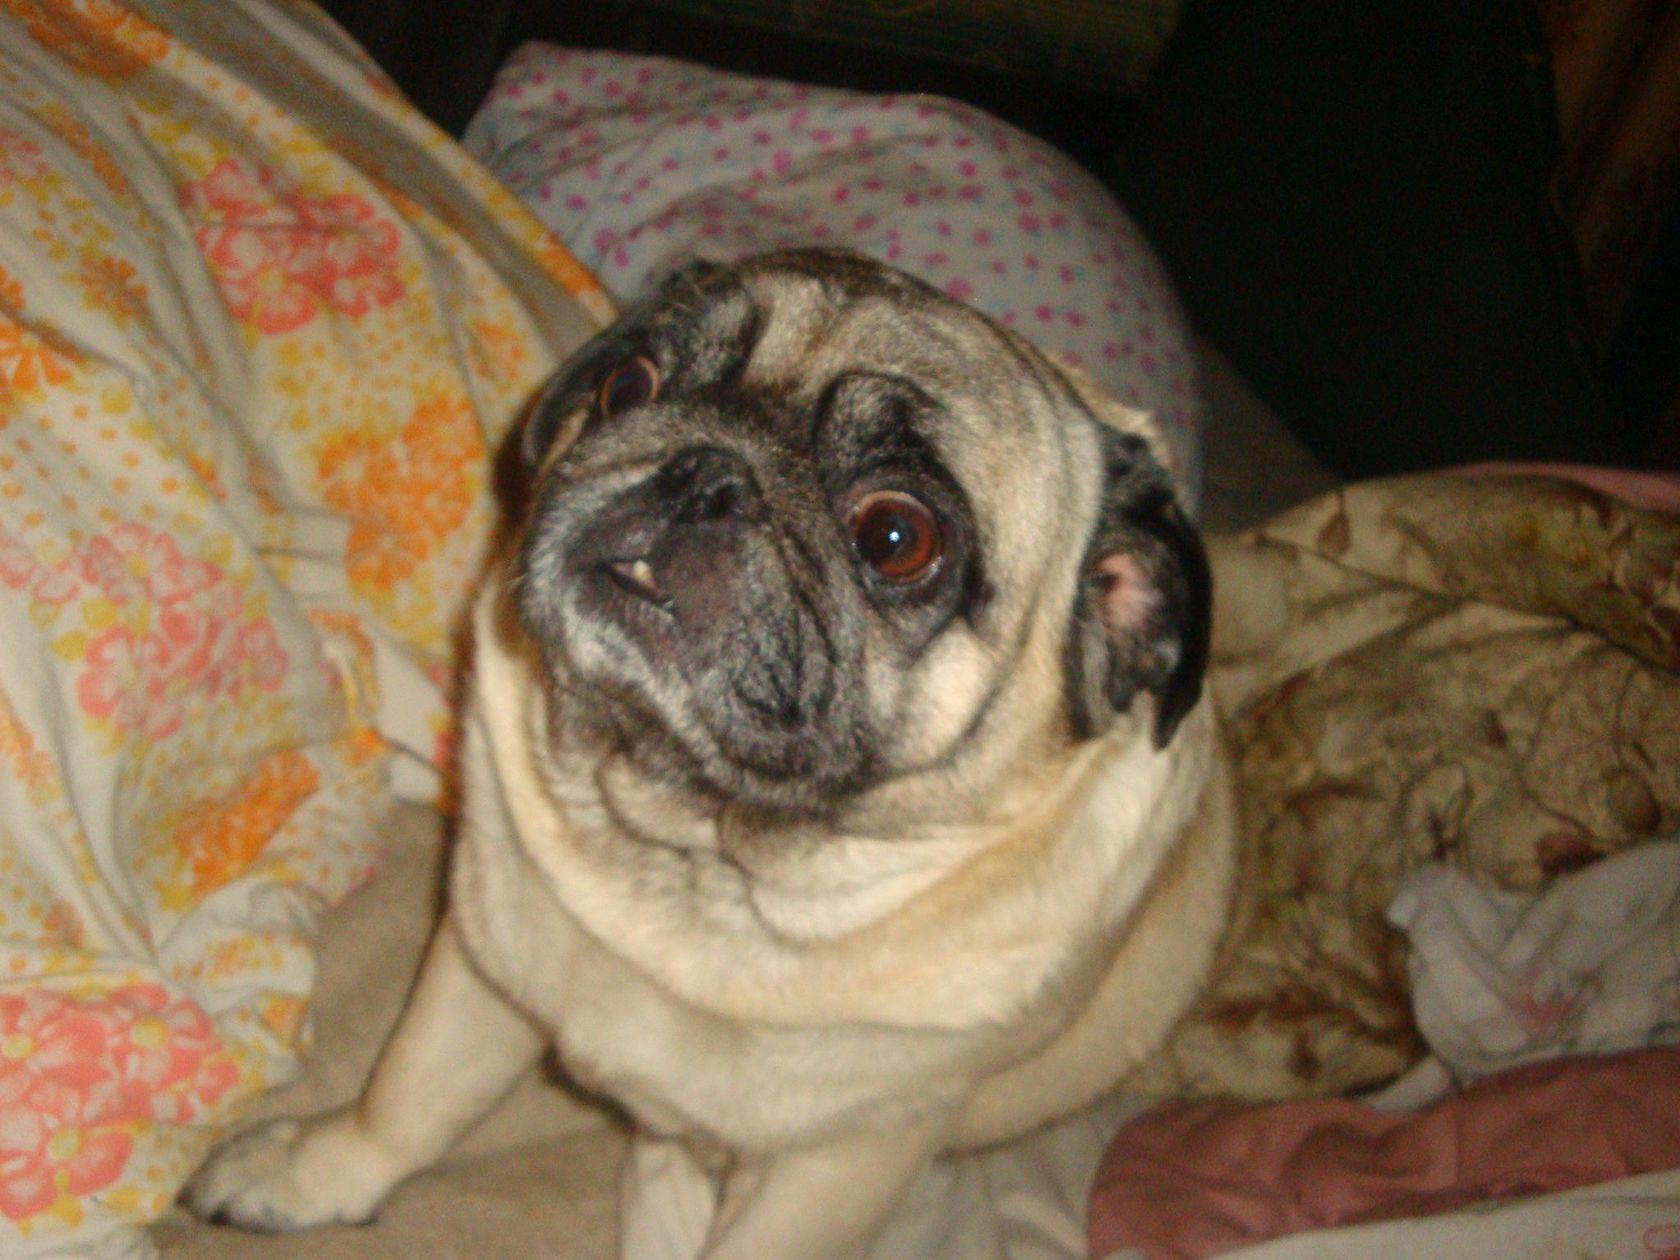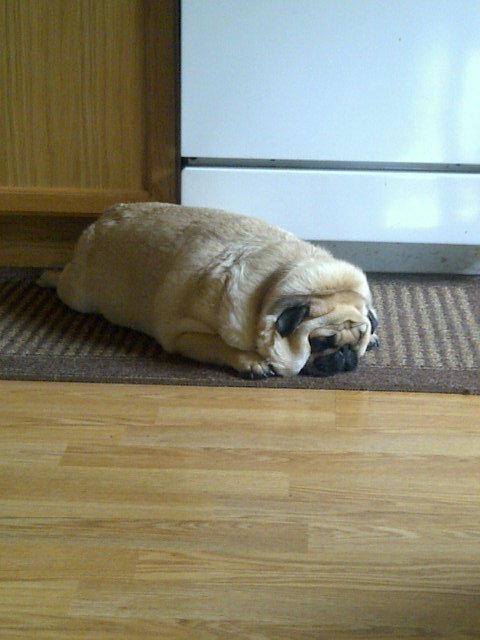The first image is the image on the left, the second image is the image on the right. For the images shown, is this caption "Each image shows one fat beige pug in a sitting pose, and no pugs are wearing outfits." true? Answer yes or no. No. The first image is the image on the left, the second image is the image on the right. Evaluate the accuracy of this statement regarding the images: "One dog has its front paws off the ground.". Is it true? Answer yes or no. No. 